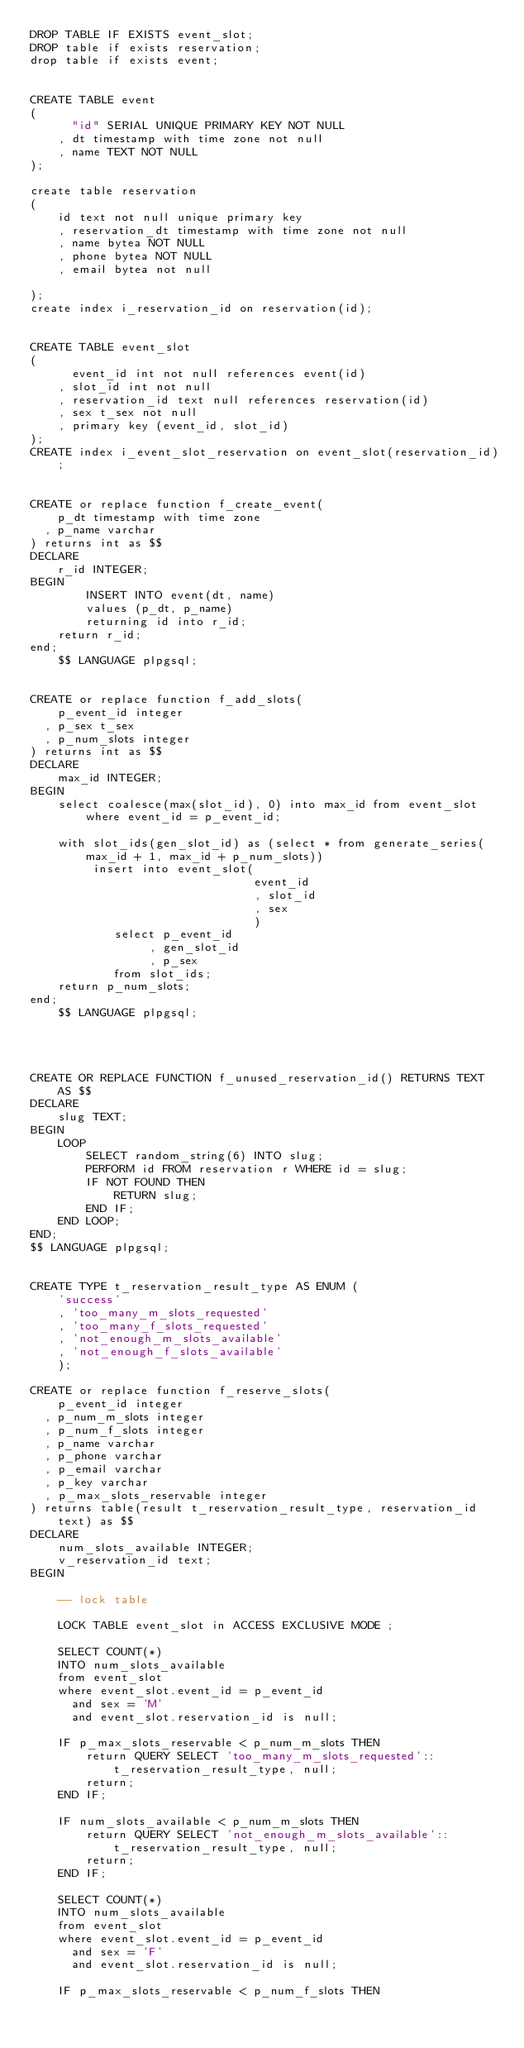<code> <loc_0><loc_0><loc_500><loc_500><_SQL_>DROP TABLE IF EXISTS event_slot;
DROP table if exists reservation;
drop table if exists event;


CREATE TABLE event
(
      "id" SERIAL UNIQUE PRIMARY KEY NOT NULL
    , dt timestamp with time zone not null
    , name TEXT NOT NULL
);

create table reservation
(
    id text not null unique primary key
    , reservation_dt timestamp with time zone not null
    , name bytea NOT NULL
    , phone bytea NOT NULL
    , email bytea not null

);
create index i_reservation_id on reservation(id);


CREATE TABLE event_slot
(
      event_id int not null references event(id)
    , slot_id int not null
    , reservation_id text null references reservation(id)
    , sex t_sex not null
    , primary key (event_id, slot_id)
);
CREATE index i_event_slot_reservation on event_slot(reservation_id);


CREATE or replace function f_create_event(
    p_dt timestamp with time zone
  , p_name varchar
) returns int as $$
DECLARE
    r_id INTEGER;
BEGIN
        INSERT INTO event(dt, name)
        values (p_dt, p_name)
        returning id into r_id;
    return r_id;
end;
    $$ LANGUAGE plpgsql;


CREATE or replace function f_add_slots(
    p_event_id integer
  , p_sex t_sex
  , p_num_slots integer
) returns int as $$
DECLARE
    max_id INTEGER;
BEGIN
    select coalesce(max(slot_id), 0) into max_id from event_slot where event_id = p_event_id;

    with slot_ids(gen_slot_id) as (select * from generate_series(max_id + 1, max_id + p_num_slots))
         insert into event_slot(
                                event_id
                                , slot_id
                                , sex
                                )
            select p_event_id
                 , gen_slot_id
                 , p_sex
            from slot_ids;
    return p_num_slots;
end;
    $$ LANGUAGE plpgsql;




CREATE OR REPLACE FUNCTION f_unused_reservation_id() RETURNS TEXT AS $$
DECLARE
    slug TEXT;
BEGIN
    LOOP
        SELECT random_string(6) INTO slug;
        PERFORM id FROM reservation r WHERE id = slug;
        IF NOT FOUND THEN
            RETURN slug;
        END IF;
    END LOOP;
END;
$$ LANGUAGE plpgsql;


CREATE TYPE t_reservation_result_type AS ENUM (
    'success'
    , 'too_many_m_slots_requested'
    , 'too_many_f_slots_requested'
    , 'not_enough_m_slots_available'
    , 'not_enough_f_slots_available'
    );

CREATE or replace function f_reserve_slots(
    p_event_id integer
  , p_num_m_slots integer
  , p_num_f_slots integer
  , p_name varchar
  , p_phone varchar
  , p_email varchar
  , p_key varchar
  , p_max_slots_reservable integer
) returns table(result t_reservation_result_type, reservation_id text) as $$
DECLARE
    num_slots_available INTEGER;
    v_reservation_id text;
BEGIN

    -- lock table

    LOCK TABLE event_slot in ACCESS EXCLUSIVE MODE ;

    SELECT COUNT(*)
    INTO num_slots_available
    from event_slot
    where event_slot.event_id = p_event_id
      and sex = 'M'
      and event_slot.reservation_id is null;

    IF p_max_slots_reservable < p_num_m_slots THEN
        return QUERY SELECT 'too_many_m_slots_requested'::t_reservation_result_type, null;
        return;
    END IF;

    IF num_slots_available < p_num_m_slots THEN
        return QUERY SELECT 'not_enough_m_slots_available'::t_reservation_result_type, null;
        return;
    END IF;

    SELECT COUNT(*)
    INTO num_slots_available
    from event_slot
    where event_slot.event_id = p_event_id
      and sex = 'F'
      and event_slot.reservation_id is null;

    IF p_max_slots_reservable < p_num_f_slots THEN</code> 